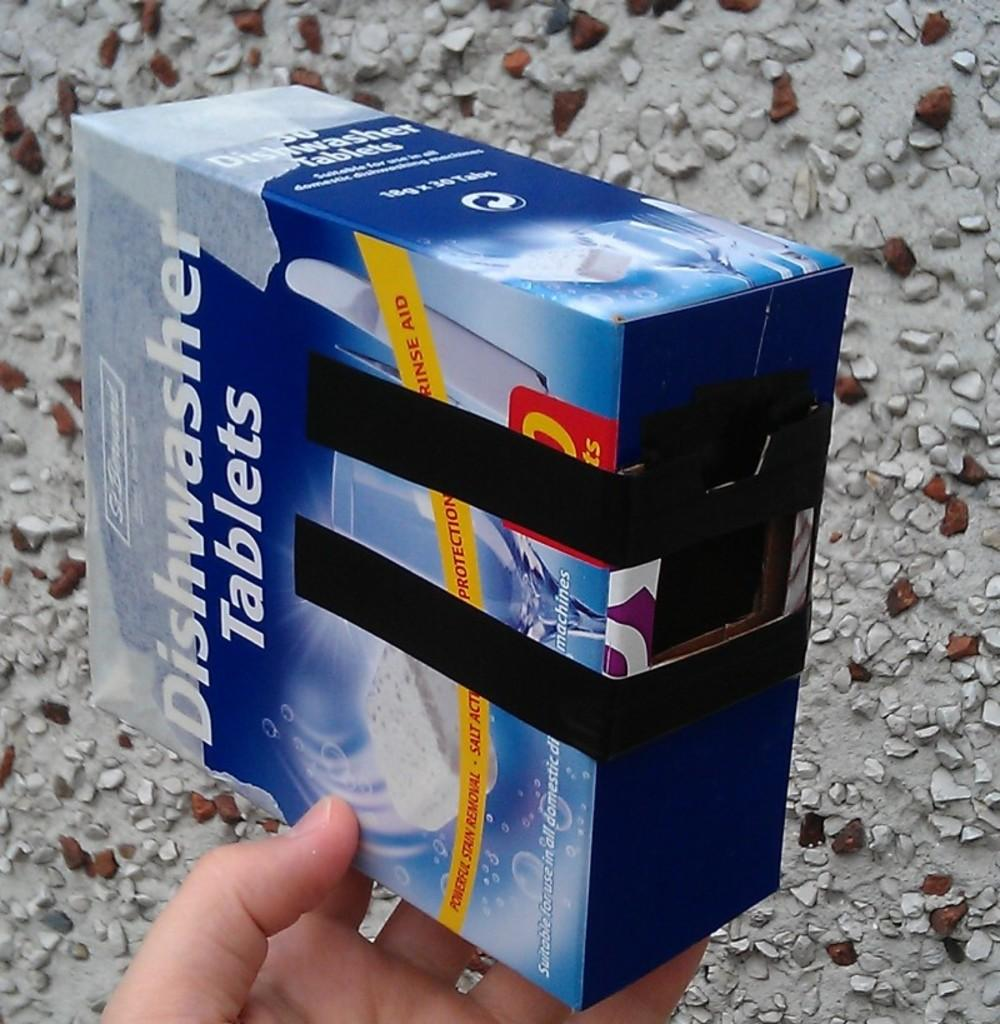<image>
Relay a brief, clear account of the picture shown. someone holding up a box that says 'dishwasher tablets' on it 